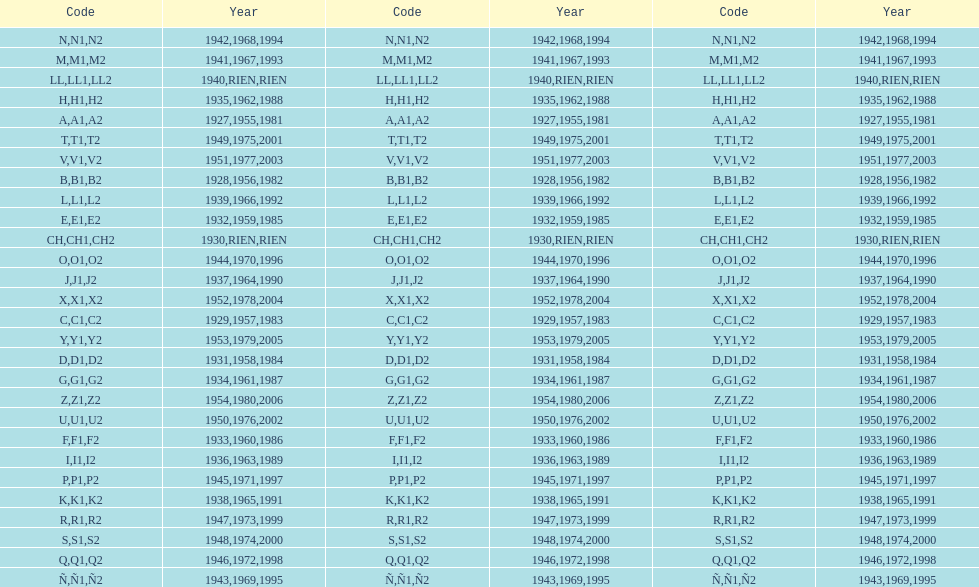How many different codes were used from 1953 to 1958? 6. 